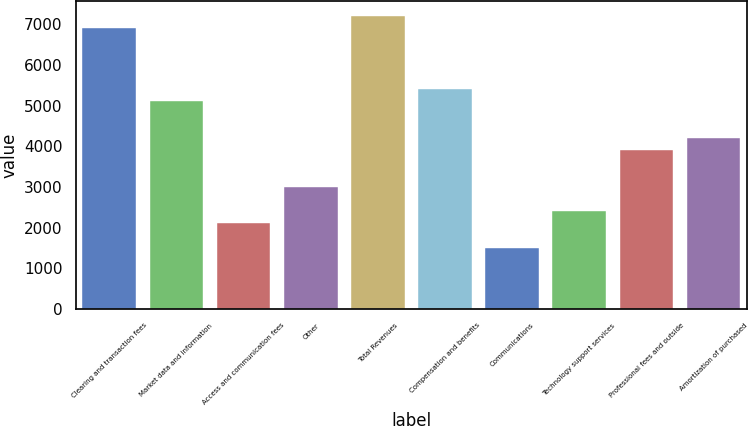Convert chart. <chart><loc_0><loc_0><loc_500><loc_500><bar_chart><fcel>Clearing and transaction fees<fcel>Market data and information<fcel>Access and communication fees<fcel>Other<fcel>Total Revenues<fcel>Compensation and benefits<fcel>Communications<fcel>Technology support services<fcel>Professional fees and outside<fcel>Amortization of purchased<nl><fcel>6907.73<fcel>5105.87<fcel>2102.77<fcel>3003.7<fcel>7208.04<fcel>5406.18<fcel>1502.15<fcel>2403.08<fcel>3904.63<fcel>4204.94<nl></chart> 